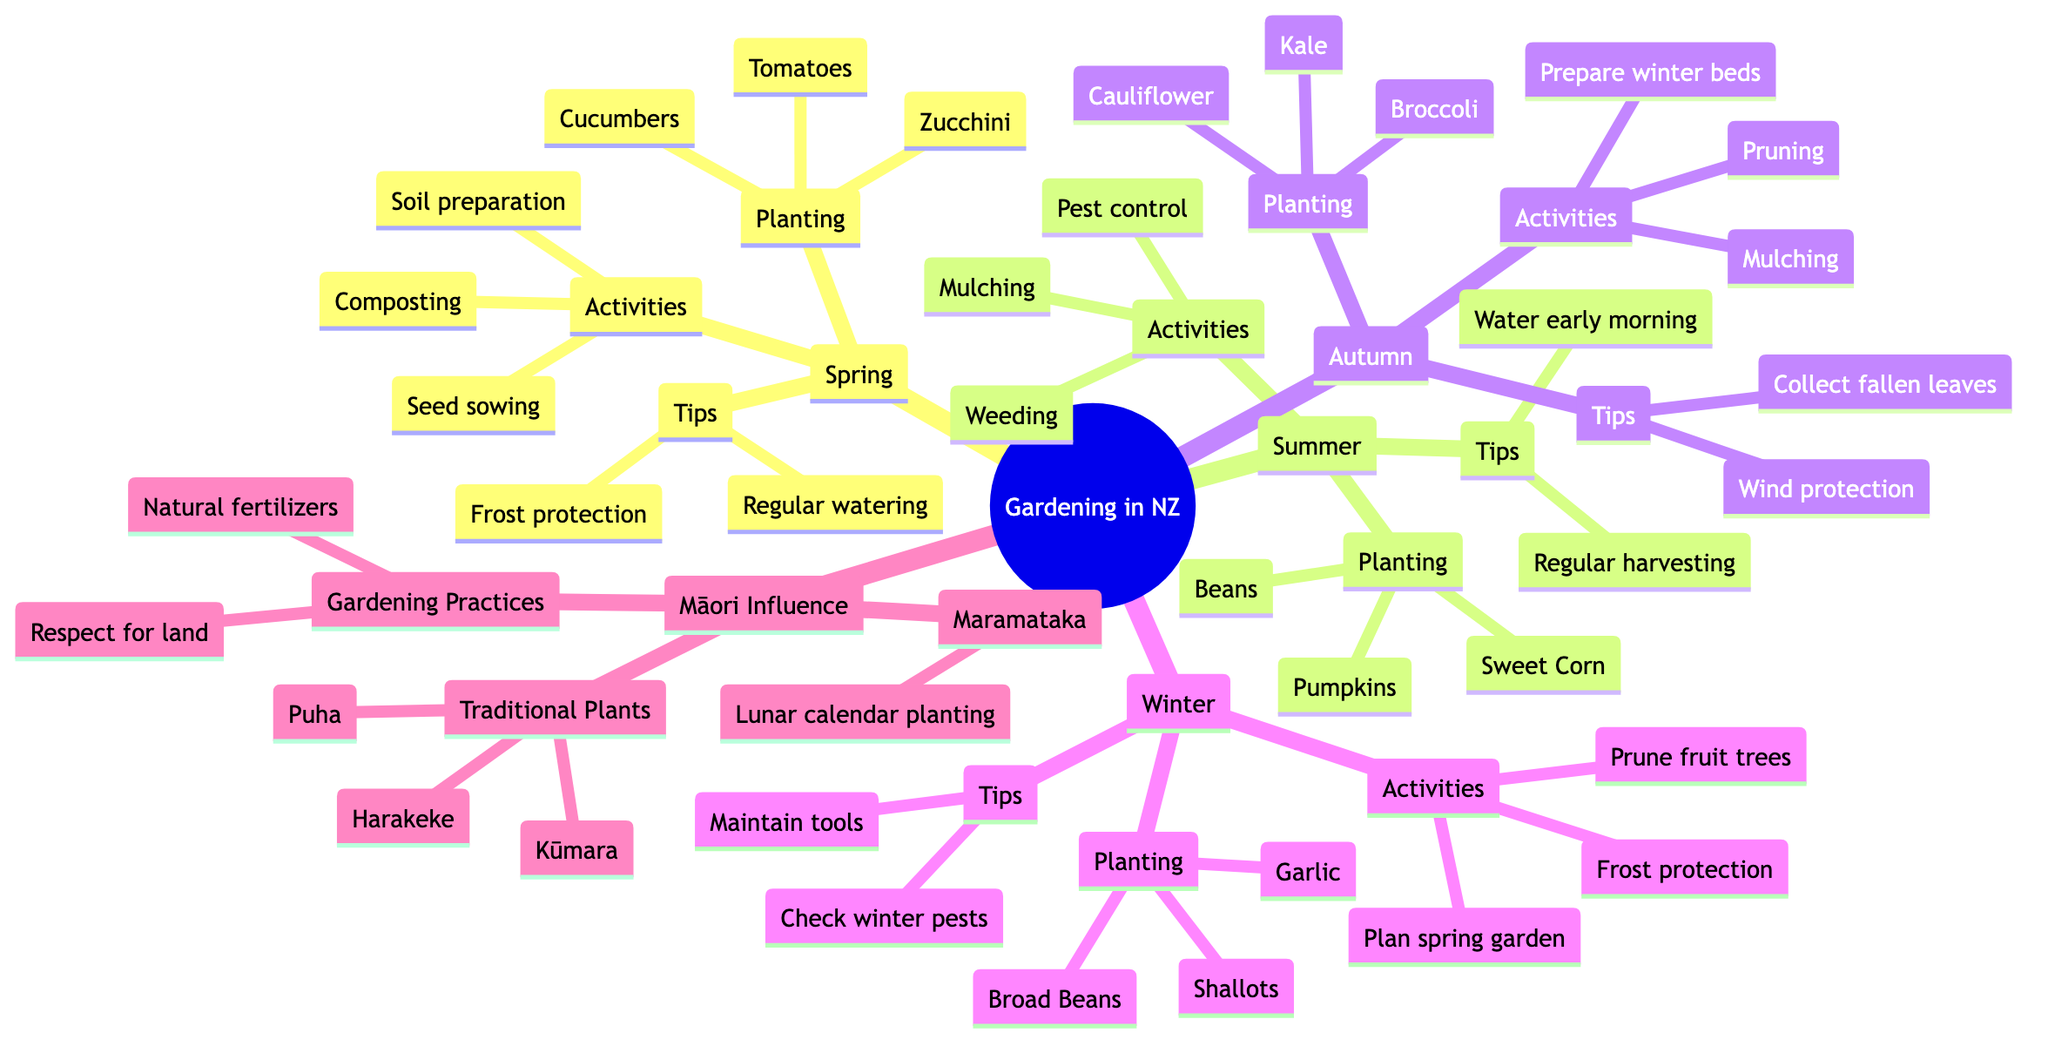What activities are suggested for Spring? The diagram lists activities under the Spring node. These activities are soil preparation, composting, and seed sowing.
Answer: Soil preparation, composting, seed sowing How many traditional plants are listed in the Māori Influence section? Looking under the Māori Influence section, there are three traditional plants listed: Kūmara, Harakeke (Flax), and Puha (Sow Thistle). Therefore, the count is three.
Answer: 3 Which season suggests planting garlic? The Winter section includes a sub-node for planting and lists garlic as one of the plants for that season.
Answer: Winter What is a tip for summer gardening? Under the Summer section, one of the tips is to "water in the early morning." This is explicitly stated under that node.
Answer: Water early morning What are the gardening practices highlighted in the Māori Influence section? The Māori Influence section includes gardening practices which are the use of natural fertilizers and respecting the land and environment. These two points are clearly laid out under this section.
Answer: Natural fertilizers, Respecting the land Which season has pruning as an activity? Both Spring and Autumn sections list pruning as an activity. However, focusing on the Autumn section, it specifies pruning along with mulching and preparing beds for winter.
Answer: Autumn How many types of planting are suggested for Autumn? Under the Autumn section, three plants are suggested for planting: Broccoli, Cauliflower, and Kale. Therefore, the count of planting types for Autumn is three.
Answer: 3 What is the description of the Maramataka node? The Maramataka node provides a description which states "Following the Māori lunar calendar for optimal planting times." This is a specific detail found under the Māori Influence section.
Answer: Following the Māori lunar calendar for optimal planting times What is one of the tips for winter gardening activities? Looking at the Winter section, one of the tips is to "Check for winter pests." This is listed among other winter gardening tips.
Answer: Check for winter pests 